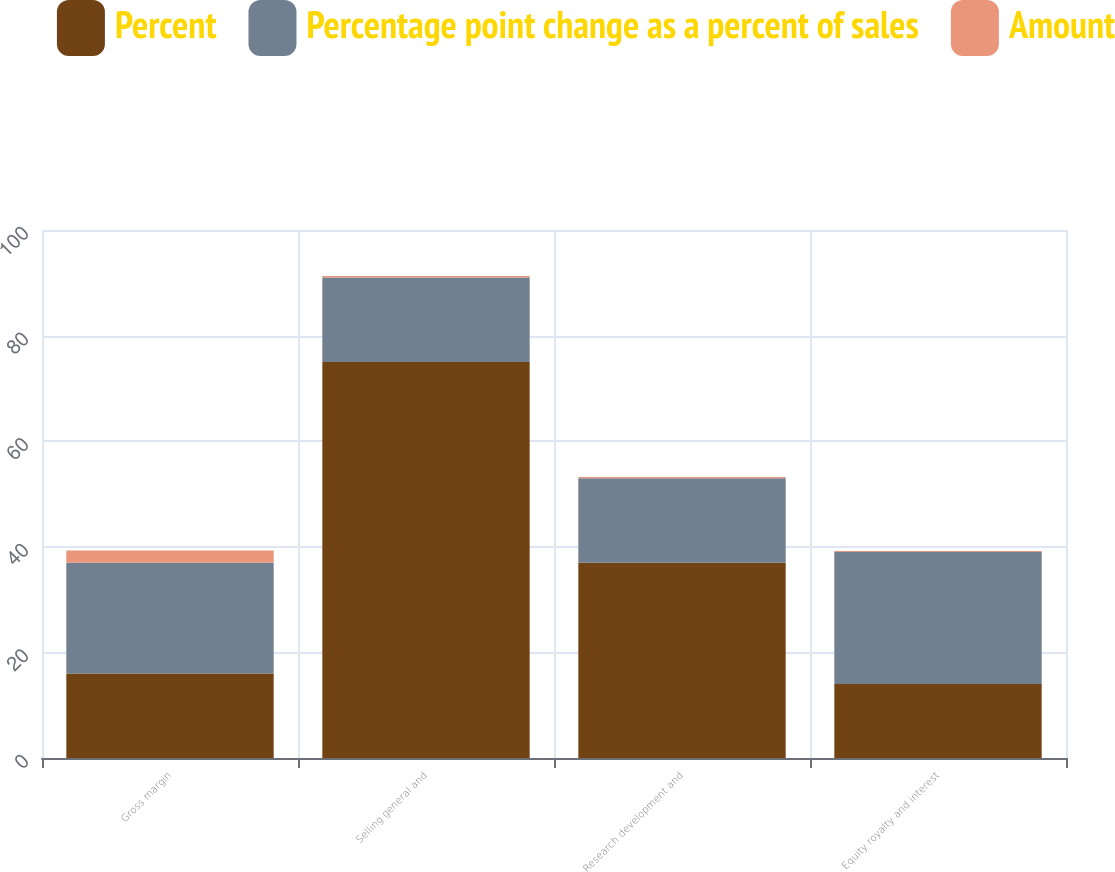<chart> <loc_0><loc_0><loc_500><loc_500><stacked_bar_chart><ecel><fcel>Gross margin<fcel>Selling general and<fcel>Research development and<fcel>Equity royalty and interest<nl><fcel>Percent<fcel>16<fcel>75<fcel>37<fcel>14<nl><fcel>Percentage point change as a percent of sales<fcel>21<fcel>16<fcel>16<fcel>25<nl><fcel>Amount<fcel>2.3<fcel>0.3<fcel>0.2<fcel>0.2<nl></chart> 